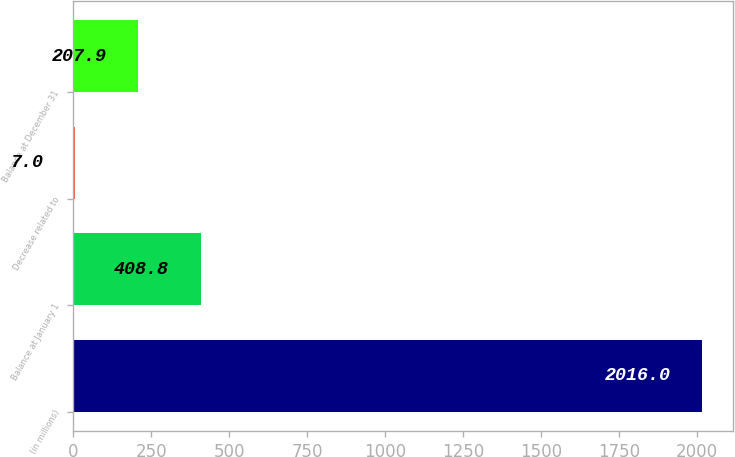Convert chart. <chart><loc_0><loc_0><loc_500><loc_500><bar_chart><fcel>(in millions)<fcel>Balance at January 1<fcel>Decrease related to<fcel>Balance at December 31<nl><fcel>2016<fcel>408.8<fcel>7<fcel>207.9<nl></chart> 